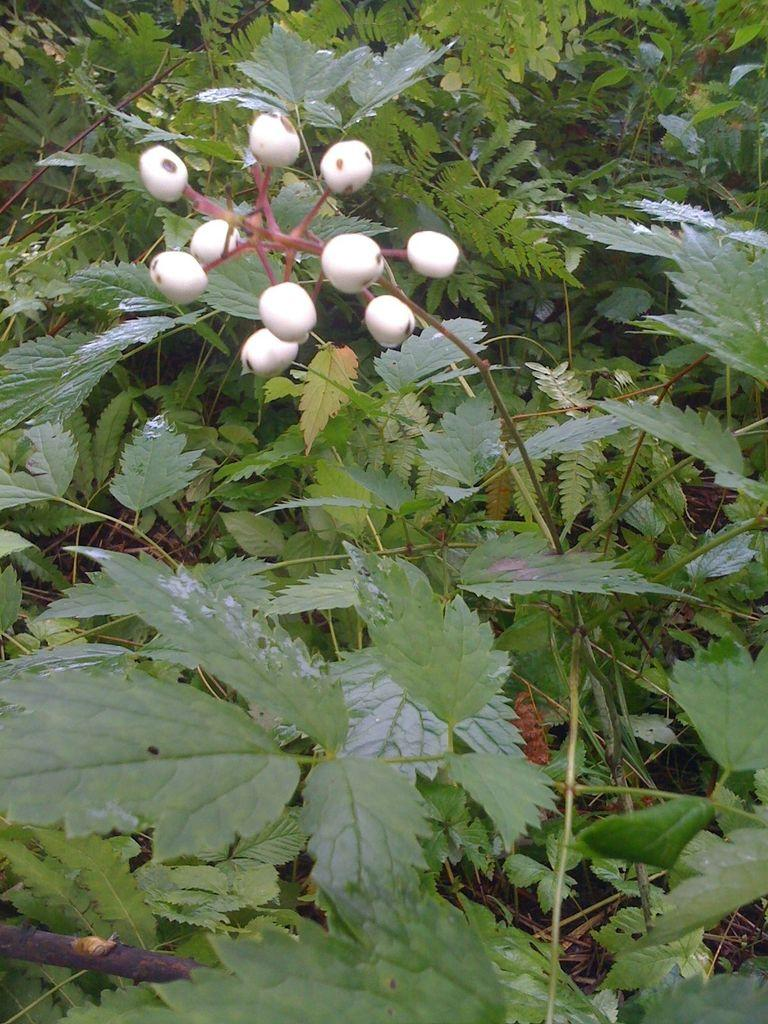What color are the leaves in the image? The leaves in the image are green. What can be seen on the top side of the image? There are white color things on the top side of the image. What type of toys are present in the image? There is no mention of toys in the provided facts, so we cannot determine if any toys are present in the image. 